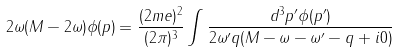Convert formula to latex. <formula><loc_0><loc_0><loc_500><loc_500>2 \omega ( M - 2 \omega ) \phi ( { p } ) = { \frac { ( 2 m e ) ^ { 2 } } { ( 2 \pi ) ^ { 3 } } } \int { \frac { d ^ { 3 } { p } ^ { \prime } \phi ( { p } ^ { \prime } ) } { 2 \omega ^ { \prime } q ( M - \omega - \omega ^ { \prime } - q + i 0 ) } }</formula> 